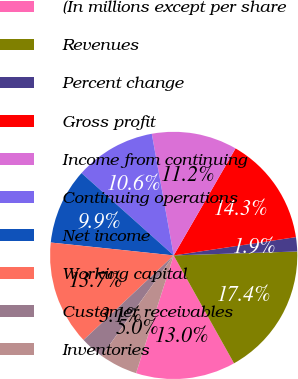Convert chart. <chart><loc_0><loc_0><loc_500><loc_500><pie_chart><fcel>(In millions except per share<fcel>Revenues<fcel>Percent change<fcel>Gross profit<fcel>Income from continuing<fcel>Continuing operations<fcel>Net income<fcel>Working capital<fcel>Customer receivables<fcel>Inventories<nl><fcel>13.04%<fcel>17.39%<fcel>1.86%<fcel>14.29%<fcel>11.18%<fcel>10.56%<fcel>9.94%<fcel>13.66%<fcel>3.11%<fcel>4.97%<nl></chart> 